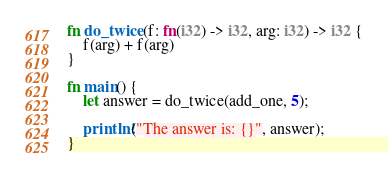<code> <loc_0><loc_0><loc_500><loc_500><_Rust_>fn do_twice(f: fn(i32) -> i32, arg: i32) -> i32 {
    f(arg) + f(arg)
}

fn main() {
    let answer = do_twice(add_one, 5);

    println!("The answer is: {}", answer);
}
</code> 